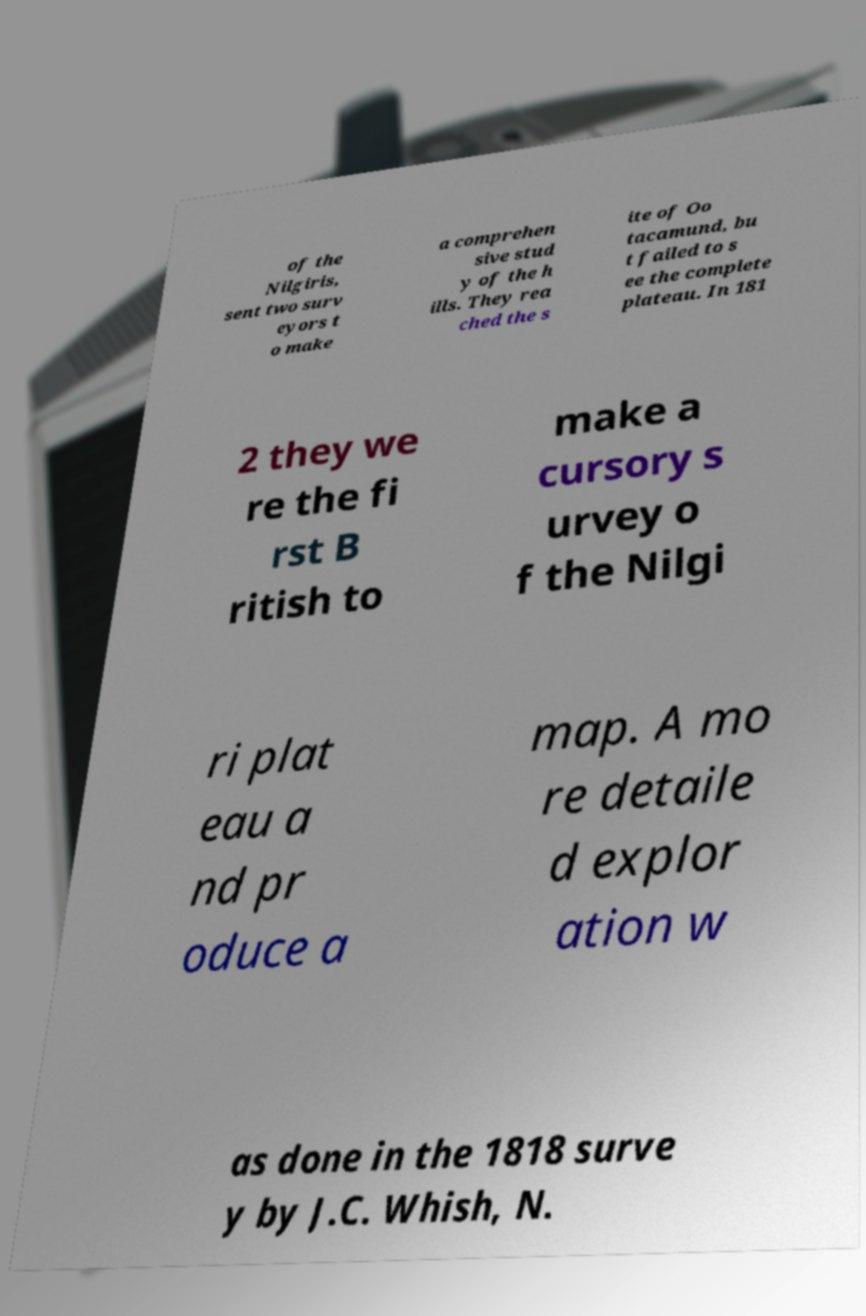Can you read and provide the text displayed in the image?This photo seems to have some interesting text. Can you extract and type it out for me? of the Nilgiris, sent two surv eyors t o make a comprehen sive stud y of the h ills. They rea ched the s ite of Oo tacamund, bu t failed to s ee the complete plateau. In 181 2 they we re the fi rst B ritish to make a cursory s urvey o f the Nilgi ri plat eau a nd pr oduce a map. A mo re detaile d explor ation w as done in the 1818 surve y by J.C. Whish, N. 